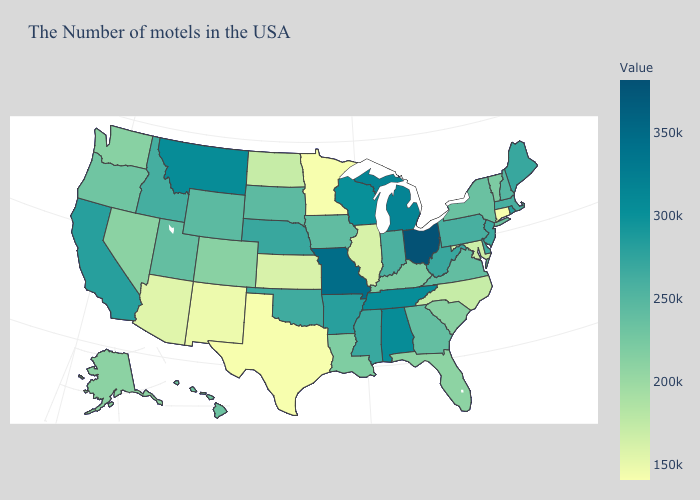Among the states that border Florida , which have the lowest value?
Be succinct. Georgia. Which states have the lowest value in the USA?
Keep it brief. Connecticut, Minnesota, Texas. Which states have the lowest value in the USA?
Be succinct. Connecticut, Minnesota, Texas. Which states have the highest value in the USA?
Short answer required. Ohio. Among the states that border Oklahoma , which have the highest value?
Short answer required. Missouri. Does Ohio have the highest value in the USA?
Quick response, please. Yes. Does Alabama have the highest value in the South?
Quick response, please. Yes. Does Oregon have the highest value in the West?
Quick response, please. No. 